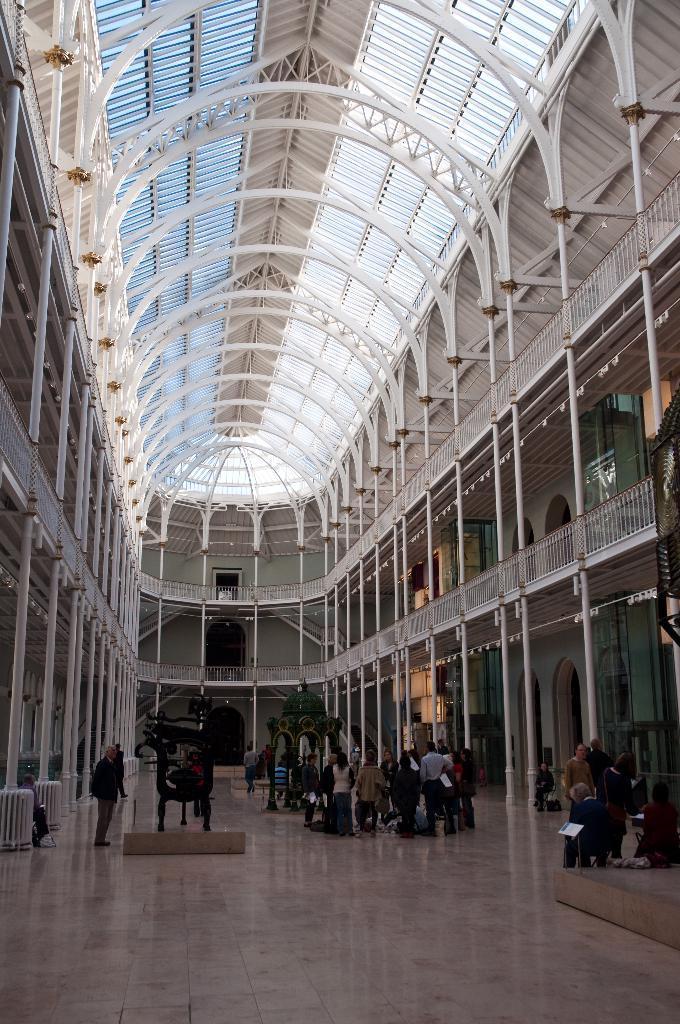In one or two sentences, can you explain what this image depicts? In this picture there are doors on the right and left side of the image and there is staircase in the center of the image, there are people on the right and left side of the image, there is a roof at the top side of the image. 